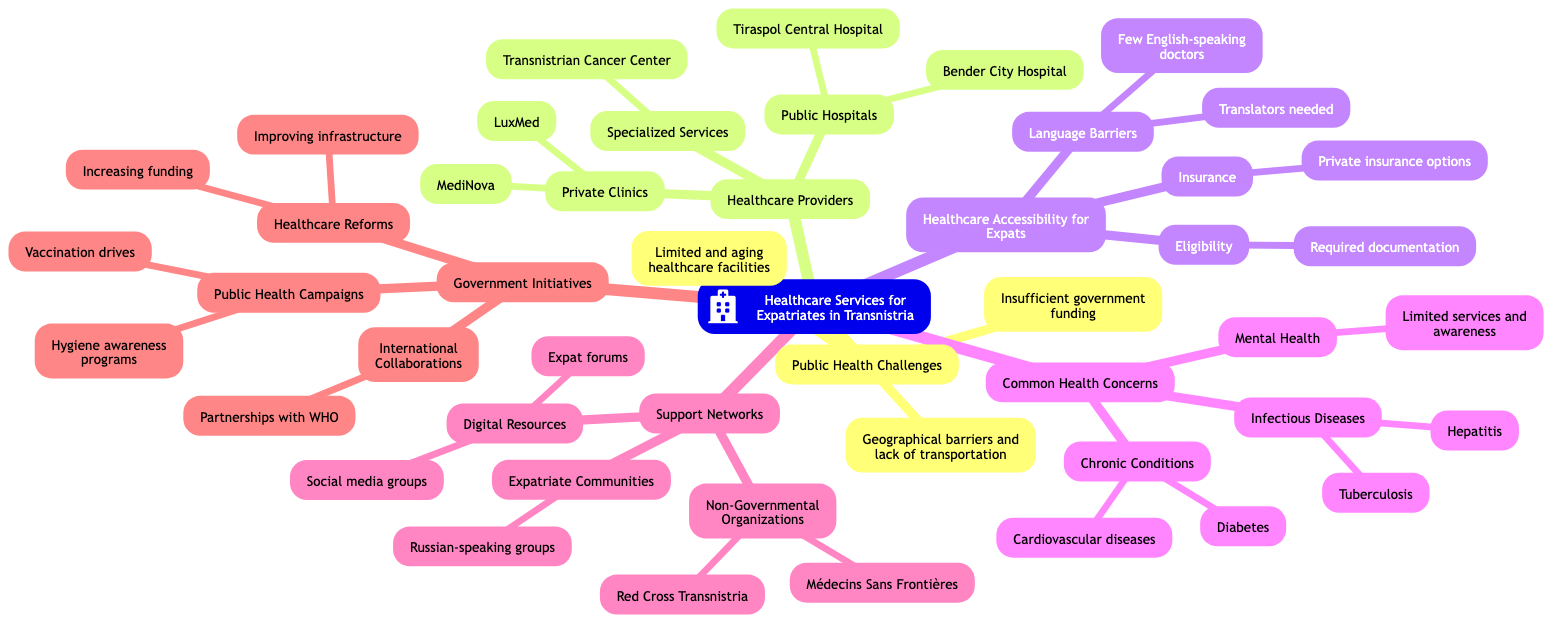What are the public hospitals listed in the diagram? The diagram specifies two public hospitals: Tiraspol Central Hospital and Bender City Hospital, which are under the "Healthcare Providers" section in the mind map.
Answer: Tiraspol Central Hospital, Bender City Hospital How many areas are covered under "Common Health Concerns"? The "Common Health Concerns" category includes three areas: Infectious Diseases, Chronic Conditions, and Mental Health. The count can be obtained by simply referencing the nodes within that section.
Answer: 3 What type of organizations are included in the "Support Networks"? Within the "Support Networks," there are three types: Expatriate Communities, Non-Governmental Organizations, and Digital Resources, highlighting the various forms of support available to expatriates in Transnistria.
Answer: Expatriate Communities, Non-Governmental Organizations, Digital Resources What is the main public health campaign mentioned? The diagram lists "Vaccination drives" as a specific public health campaign under the "Government Initiatives" section, indicating proactive healthcare measures being taken for public health.
Answer: Vaccination drives Why might expatriates face challenges accessing healthcare? The reasons include language barriers (due to few English-speaking doctors), eligibility issues related to required documentation, and the availability of private insurance options, all of which are interlinked factors in the "Healthcare Accessibility for Expats" section.
Answer: Language barriers, eligibility, insurance Which healthcare service is specialized for cancer? The specialized service for cancer is the "Transnistrian Cancer Center," identified under the "Healthcare Providers" section, emphasizing a dedicated facility for that specific health concern.
Answer: Transnistrian Cancer Center How many types of health concerns are chronic conditions mentioned in the mind map? The mind map indicates that "Chronic Conditions" includes two specific concerns: Cardiovascular diseases and Diabetes, falling under the "Common Health Concerns" category.
Answer: 2 What are the major public health challenges highlighted? The major challenges are categorized into three key areas: Limited and aging healthcare facilities, Insufficient government funding, and Geographical barriers and lack of transportation, all of which are essential issues affecting public health.
Answer: Limited and aging healthcare facilities, Insufficient government funding, Geographical barriers and lack of transportation 